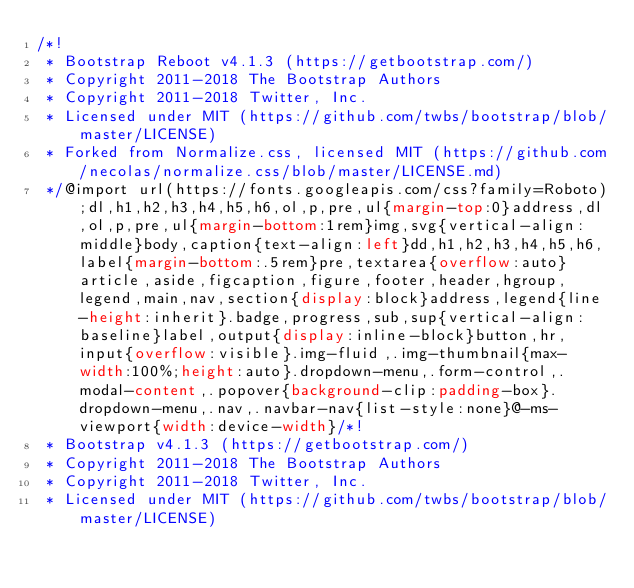<code> <loc_0><loc_0><loc_500><loc_500><_CSS_>/*!
 * Bootstrap Reboot v4.1.3 (https://getbootstrap.com/)
 * Copyright 2011-2018 The Bootstrap Authors
 * Copyright 2011-2018 Twitter, Inc.
 * Licensed under MIT (https://github.com/twbs/bootstrap/blob/master/LICENSE)
 * Forked from Normalize.css, licensed MIT (https://github.com/necolas/normalize.css/blob/master/LICENSE.md)
 */@import url(https://fonts.googleapis.com/css?family=Roboto);dl,h1,h2,h3,h4,h5,h6,ol,p,pre,ul{margin-top:0}address,dl,ol,p,pre,ul{margin-bottom:1rem}img,svg{vertical-align:middle}body,caption{text-align:left}dd,h1,h2,h3,h4,h5,h6,label{margin-bottom:.5rem}pre,textarea{overflow:auto}article,aside,figcaption,figure,footer,header,hgroup,legend,main,nav,section{display:block}address,legend{line-height:inherit}.badge,progress,sub,sup{vertical-align:baseline}label,output{display:inline-block}button,hr,input{overflow:visible}.img-fluid,.img-thumbnail{max-width:100%;height:auto}.dropdown-menu,.form-control,.modal-content,.popover{background-clip:padding-box}.dropdown-menu,.nav,.navbar-nav{list-style:none}@-ms-viewport{width:device-width}/*!
 * Bootstrap v4.1.3 (https://getbootstrap.com/)
 * Copyright 2011-2018 The Bootstrap Authors
 * Copyright 2011-2018 Twitter, Inc.
 * Licensed under MIT (https://github.com/twbs/bootstrap/blob/master/LICENSE)</code> 